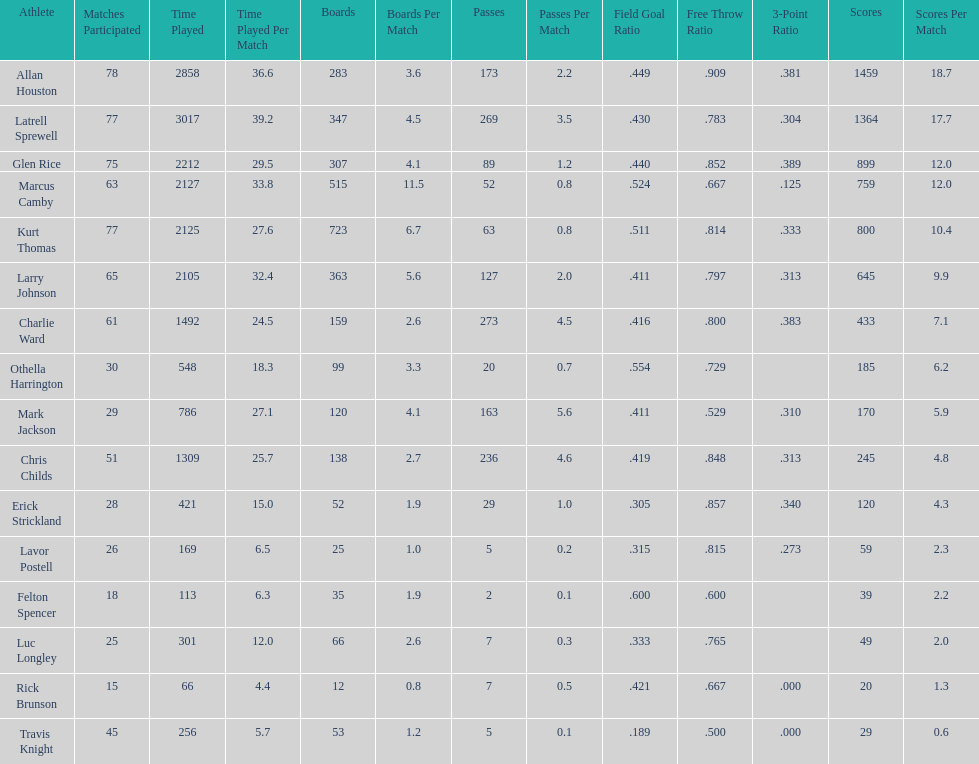Did kurt thomas play more or less than 2126 minutes? Less. Parse the full table. {'header': ['Athlete', 'Matches Participated', 'Time Played', 'Time Played Per Match', 'Boards', 'Boards Per Match', 'Passes', 'Passes Per Match', 'Field Goal Ratio', 'Free Throw Ratio', '3-Point Ratio', 'Scores', 'Scores Per Match'], 'rows': [['Allan Houston', '78', '2858', '36.6', '283', '3.6', '173', '2.2', '.449', '.909', '.381', '1459', '18.7'], ['Latrell Sprewell', '77', '3017', '39.2', '347', '4.5', '269', '3.5', '.430', '.783', '.304', '1364', '17.7'], ['Glen Rice', '75', '2212', '29.5', '307', '4.1', '89', '1.2', '.440', '.852', '.389', '899', '12.0'], ['Marcus Camby', '63', '2127', '33.8', '515', '11.5', '52', '0.8', '.524', '.667', '.125', '759', '12.0'], ['Kurt Thomas', '77', '2125', '27.6', '723', '6.7', '63', '0.8', '.511', '.814', '.333', '800', '10.4'], ['Larry Johnson', '65', '2105', '32.4', '363', '5.6', '127', '2.0', '.411', '.797', '.313', '645', '9.9'], ['Charlie Ward', '61', '1492', '24.5', '159', '2.6', '273', '4.5', '.416', '.800', '.383', '433', '7.1'], ['Othella Harrington', '30', '548', '18.3', '99', '3.3', '20', '0.7', '.554', '.729', '', '185', '6.2'], ['Mark Jackson', '29', '786', '27.1', '120', '4.1', '163', '5.6', '.411', '.529', '.310', '170', '5.9'], ['Chris Childs', '51', '1309', '25.7', '138', '2.7', '236', '4.6', '.419', '.848', '.313', '245', '4.8'], ['Erick Strickland', '28', '421', '15.0', '52', '1.9', '29', '1.0', '.305', '.857', '.340', '120', '4.3'], ['Lavor Postell', '26', '169', '6.5', '25', '1.0', '5', '0.2', '.315', '.815', '.273', '59', '2.3'], ['Felton Spencer', '18', '113', '6.3', '35', '1.9', '2', '0.1', '.600', '.600', '', '39', '2.2'], ['Luc Longley', '25', '301', '12.0', '66', '2.6', '7', '0.3', '.333', '.765', '', '49', '2.0'], ['Rick Brunson', '15', '66', '4.4', '12', '0.8', '7', '0.5', '.421', '.667', '.000', '20', '1.3'], ['Travis Knight', '45', '256', '5.7', '53', '1.2', '5', '0.1', '.189', '.500', '.000', '29', '0.6']]} 